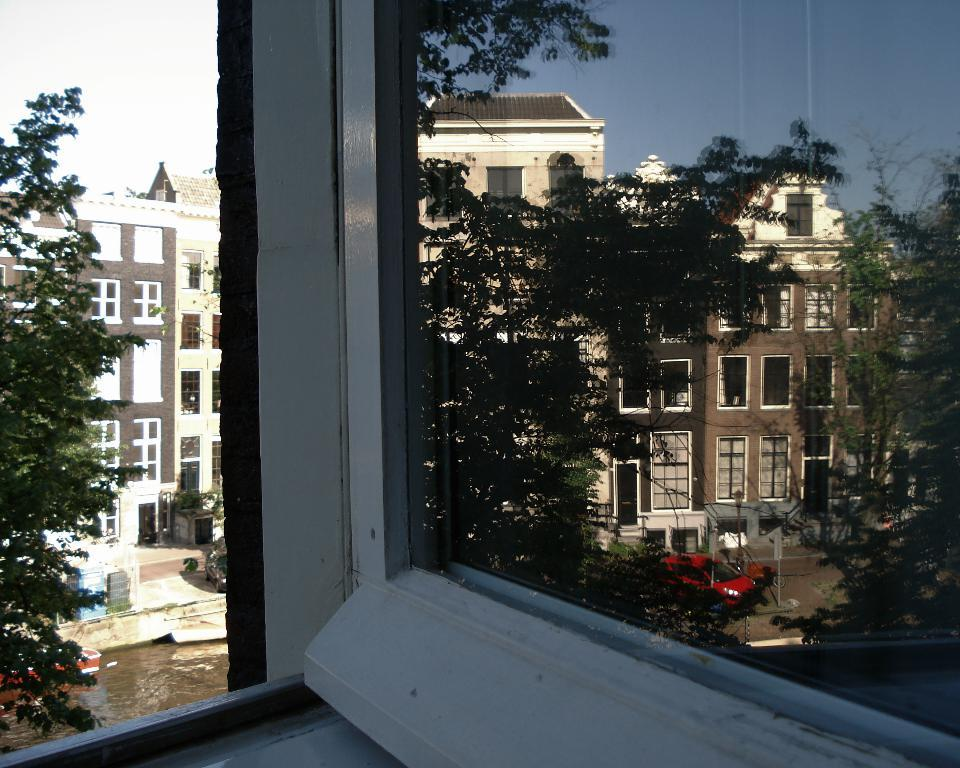What type of transparent barrier is present in the image? There is a glass window in the image. What can be seen through the glass window? Vehicles and buildings are visible behind the window. What part of the natural environment is visible in the image? The sky is visible in the image. What is the rate of the slip in the image? There is no slip present in the image, so it is not possible to determine a rate. 